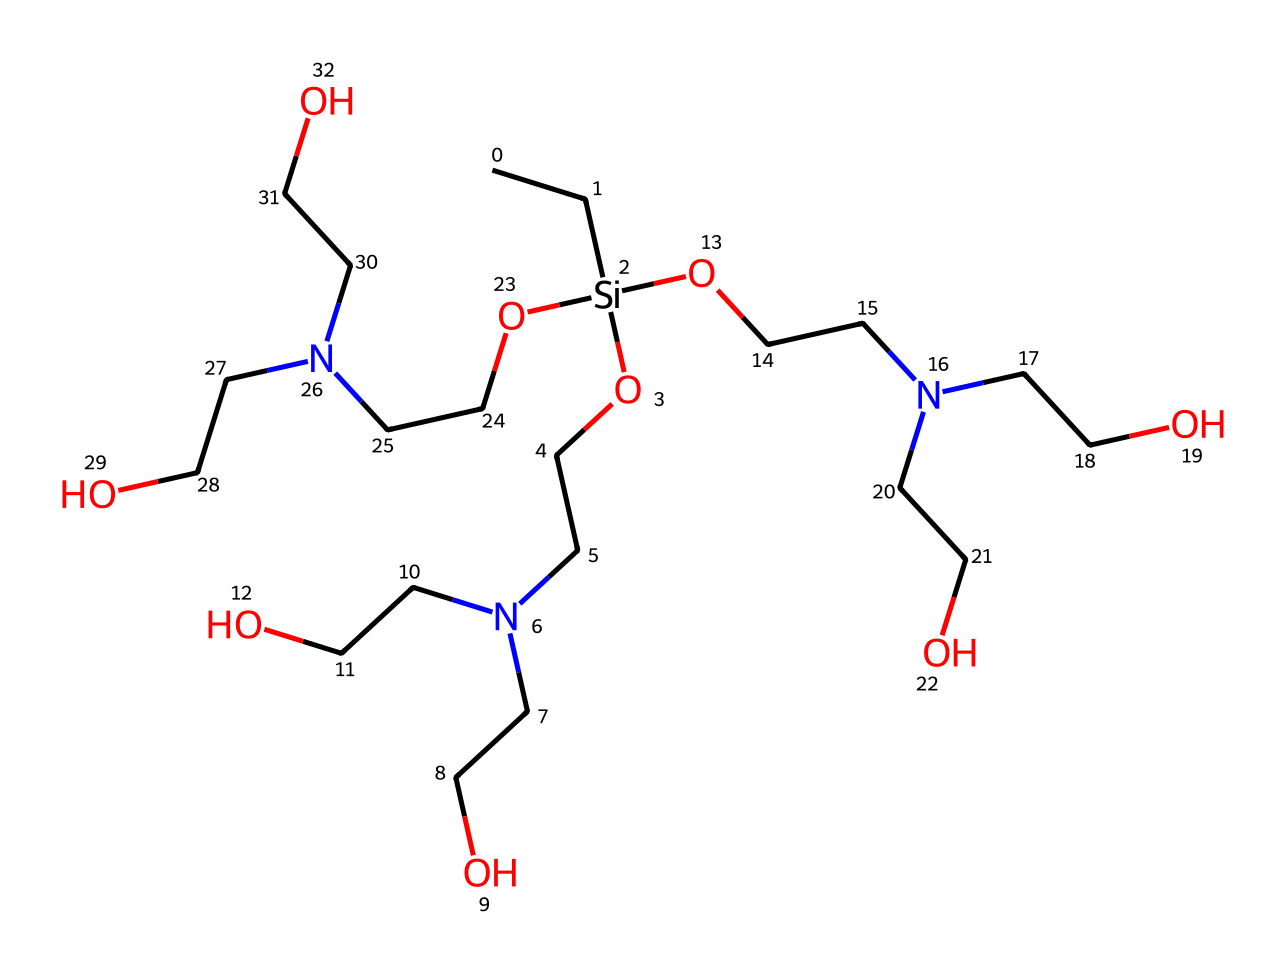What is the main functional group in this silane? The presence of the silicon atom bonded to multiple oxygen atoms (represented as -Si(OR)3) indicates that the main functional group here is a silanol group. This group features the silicon atom (Si) central to the structure, which is characteristic of silanes.
Answer: silanol How many nitrogen atoms are present? By examining the SMILES representation, there are multiple 'N' characters, indicating nitrogen atoms. Counting them yields a total of three nitrogen atoms in the structure, each connected to the branching alkyl groups.
Answer: three How many carbon atoms are connected to silicon in this chemical? The structure shows multiple carbon chains (the "CC" groups in the SMILES) directly connected to the silicon. Upon counting all distinct carbon atoms, there are a total of six carbon atoms connected to the silicon atom.
Answer: six What type of bonds are mainly found in this silane? Analyzing the structure, the bonds formed between silicon and the surrounding atoms (carbon, nitrogen, and oxygen) are primarily covalent bonds. Due to the valence of silicon and the presence of organic groups, these bonds dominate the molecular structure.
Answer: covalent What is a potential application of this silane in military uniforms? Silane-based flame retardants improve the resistance of fabrics to ignition and reduce flammability, which is crucial for military uniforms exposed to hazardous conditions. This application greatly enhances safety for personnel.
Answer: flame retardant 